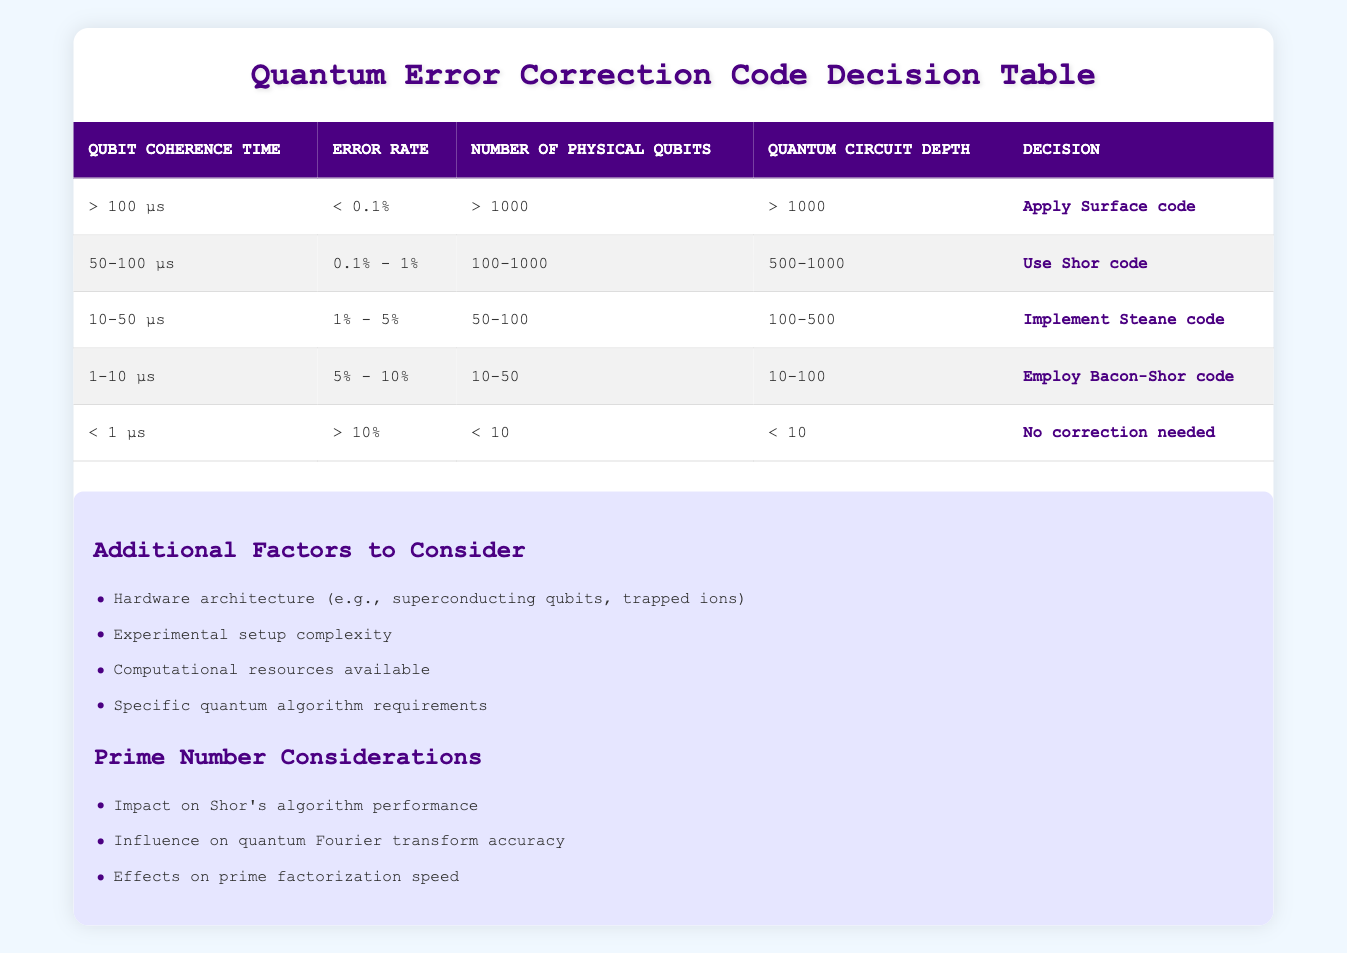What decision is recommended if the error rate is between 0.1% and 1%? From the table, under the condition where the error rate is specified as between 0.1% and 1%, the corresponding decision in that row is to "Use Shor code."
Answer: Use Shor code How many physical qubits are needed to apply the Surface code? In the table, the condition for applying the Surface code requires that the number of physical qubits be greater than 1000.
Answer: > 1000 What is the error rate threshold for "No correction needed"? According to the last row of the table, "No correction needed" occurs when the error rate is greater than 10%.
Answer: > 10% If the qubit coherence time is 50 μs and the quantum circuit depth is 600, which code is applied? The coherence time falls in the range of 50-100 μs, and the circuit depth is 600, which falls between 500-1000. According to the relevant row in the table, the recommended action is to "Use Shor code."
Answer: Use Shor code Are there any quantum error correction codes for a coherence time of less than 1 μs? The table indicates that if the coherence time is less than 1 μs and the error rate exceeds 10% with fewer than 10 physical qubits, then the action is "No correction needed." Thus, there is no correction code applied in this case.
Answer: No What conditions lead to implementing the Steane code? The conditions required for "Implement Steane code" are a qubit coherence time of 10-50 μs, an error rate of 1% to 5%, a number of physical qubits ranging from 50 to 100, and a quantum circuit depth between 100 to 500.
Answer: Coherence time 10-50 μs, error rate 1%-5%, 50-100 qubits, depth 100-500 What is the maximum error rate tolerated when employing the Bacon-Shor code? The Bacon-Shor code is employed when the error rate is in the range of 5% to 10%, as indicated in the relevant row of the table.
Answer: 5% - 10% If we have 150 physical qubits, which quantum error correction code should be used? With 150 physical qubits, we check the relevant conditions: this quantity falls within the range of 100-1000 physical qubits. If we also consider an error rate and circuit depth that match those for the "Use Shor code," that is the correct action. Thus, the code to use is "Use Shor code."
Answer: Use Shor code 